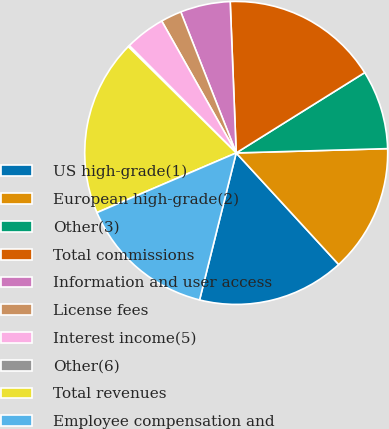<chart> <loc_0><loc_0><loc_500><loc_500><pie_chart><fcel>US high-grade(1)<fcel>European high-grade(2)<fcel>Other(3)<fcel>Total commissions<fcel>Information and user access<fcel>License fees<fcel>Interest income(5)<fcel>Other(6)<fcel>Total revenues<fcel>Employee compensation and<nl><fcel>15.71%<fcel>13.63%<fcel>8.44%<fcel>16.74%<fcel>5.33%<fcel>2.22%<fcel>4.29%<fcel>0.15%<fcel>18.82%<fcel>14.67%<nl></chart> 